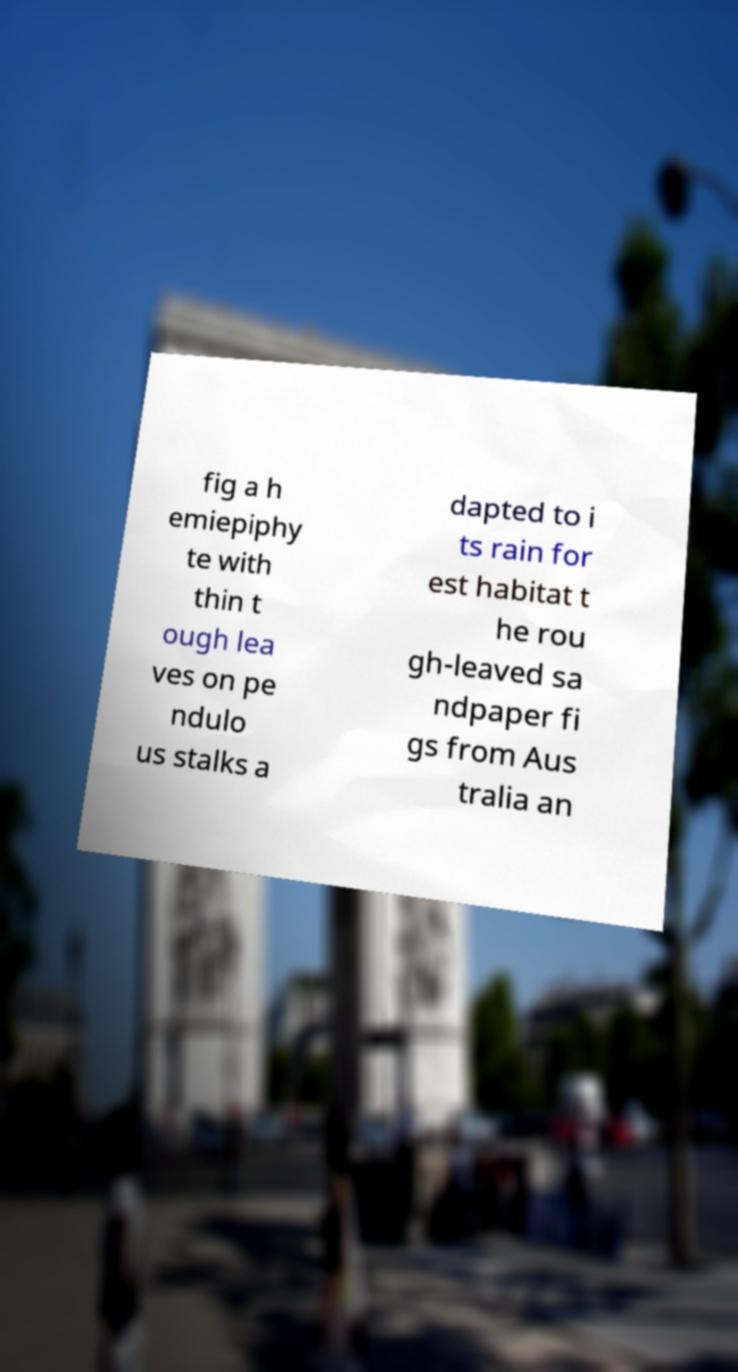Please read and relay the text visible in this image. What does it say? fig a h emiepiphy te with thin t ough lea ves on pe ndulo us stalks a dapted to i ts rain for est habitat t he rou gh-leaved sa ndpaper fi gs from Aus tralia an 